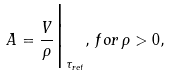Convert formula to latex. <formula><loc_0><loc_0><loc_500><loc_500>A = \frac { V } { \rho } { \Big | } _ { { \tau } _ { r e t } } , \, f o r \, \rho > 0 ,</formula> 